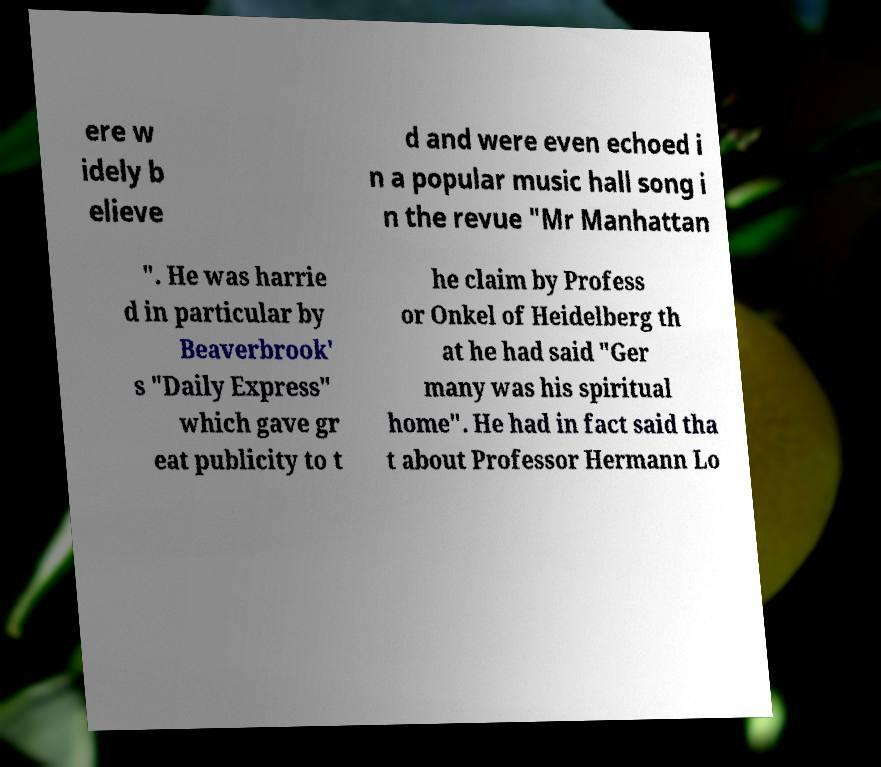Please read and relay the text visible in this image. What does it say? ere w idely b elieve d and were even echoed i n a popular music hall song i n the revue "Mr Manhattan ". He was harrie d in particular by Beaverbrook' s "Daily Express" which gave gr eat publicity to t he claim by Profess or Onkel of Heidelberg th at he had said "Ger many was his spiritual home". He had in fact said tha t about Professor Hermann Lo 